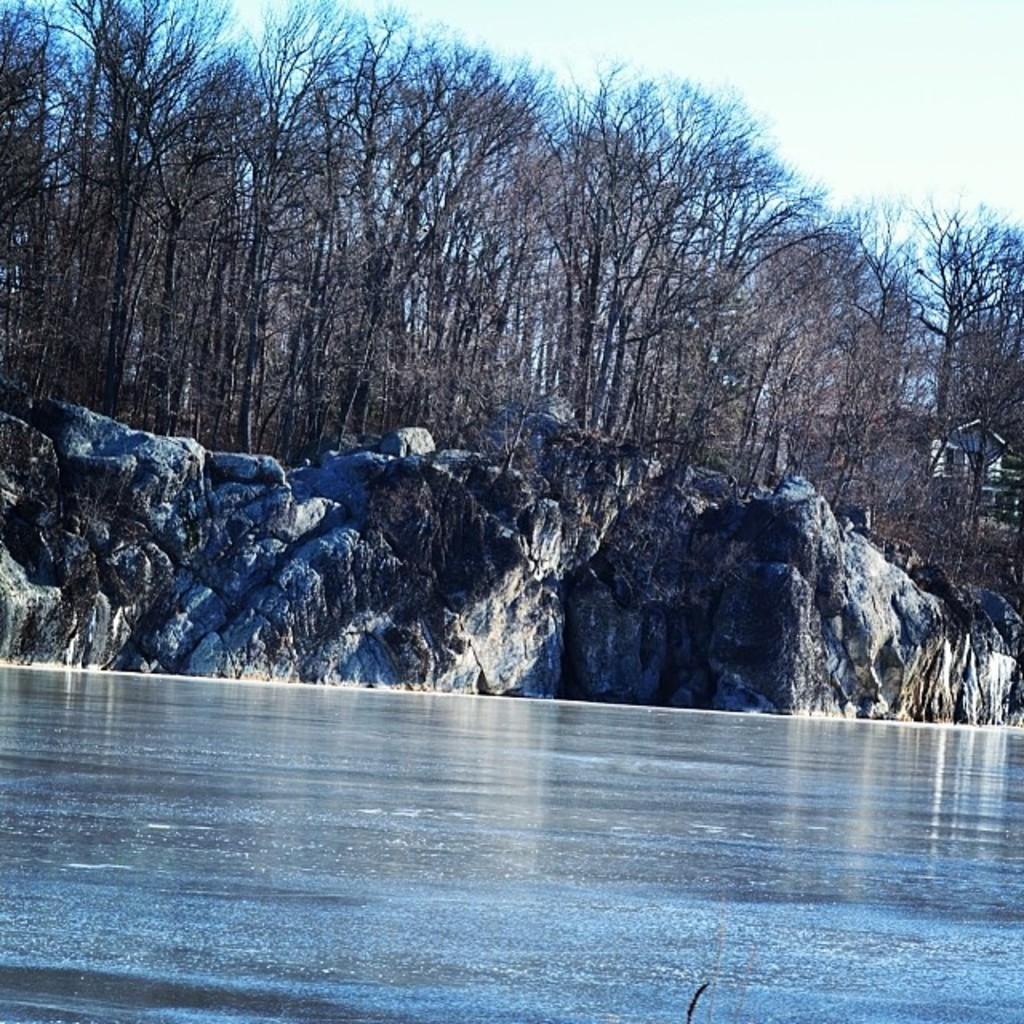What is the main feature in the foreground of the picture? There is a water body in the foreground of the picture. What can be seen in the center of the picture? There are trees and a rock in the center of the picture. What is located in the background towards the right? There is a house in the background towards the right. Where is the scarecrow standing in the image? There is no scarecrow present in the image. What type of crib is visible in the image? There is no crib present in the image. 